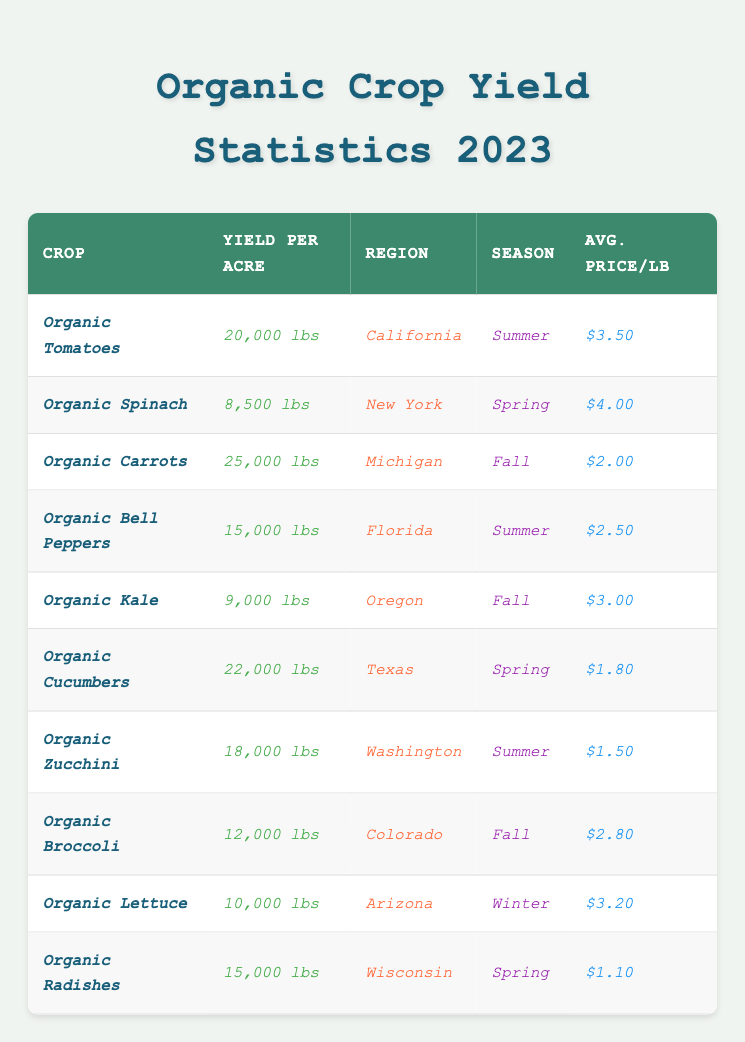What is the highest yield per acre among the organic vegetables? The table shows that Organic Carrots have the highest yield per acre at 25,000 lbs compared to other crops.
Answer: 25,000 lbs Which crop has the lowest average price per pound? By comparing the average prices listed, Organic Radishes have the lowest price at $1.10 per pound.
Answer: $1.10 How many crops have a yield per acre of more than 15,000 lbs? The crops with a yield over 15,000 lbs are Organic Tomatoes, Organic Carrots, and Organic Cucumbers. This totals to 3 crops.
Answer: 3 Which region produces Organic Kale? The table indicates that Organic Kale is produced in Oregon.
Answer: Oregon What is the yield difference between Organic Cucumbers and Organic Bell Peppers? Organic Cucumbers yield 22,000 lbs, while Organic Bell Peppers yield 15,000 lbs. The difference is 22,000 - 15,000 = 7,000 lbs.
Answer: 7,000 lbs How many of the featured crops are grown in the Spring season? The crops grown in Spring are Organic Spinach, Organic Cucumbers, and Organic Radishes, totaling to 3.
Answer: 3 Which crop yields 10,000 lbs per acre? The table shows that Organic Lettuce has a yield of 10,000 lbs per acre.
Answer: Organic Lettuce Is the average price of Organic Tomatoes higher than that of Organic Carrots? Organic Tomatoes have an average price of $3.50, while Organic Carrots have an average price of $2.00. Since $3.50 > $2.00, the statement is true.
Answer: Yes What is the total yield per acre for the crops grown in Winter? The only crop grown in Winter is Organic Lettuce with a yield of 10,000 lbs, so the total yield is 10,000 lbs.
Answer: 10,000 lbs If a farmer grows one acre of Organic Zucchini and sells the entire yield, how much revenue would they generate? Organic Zucchini yields 18,000 lbs, and the average price per pound is $1.50. Calculating revenue: 18,000 lbs * $1.50 = $27,000.
Answer: $27,000 